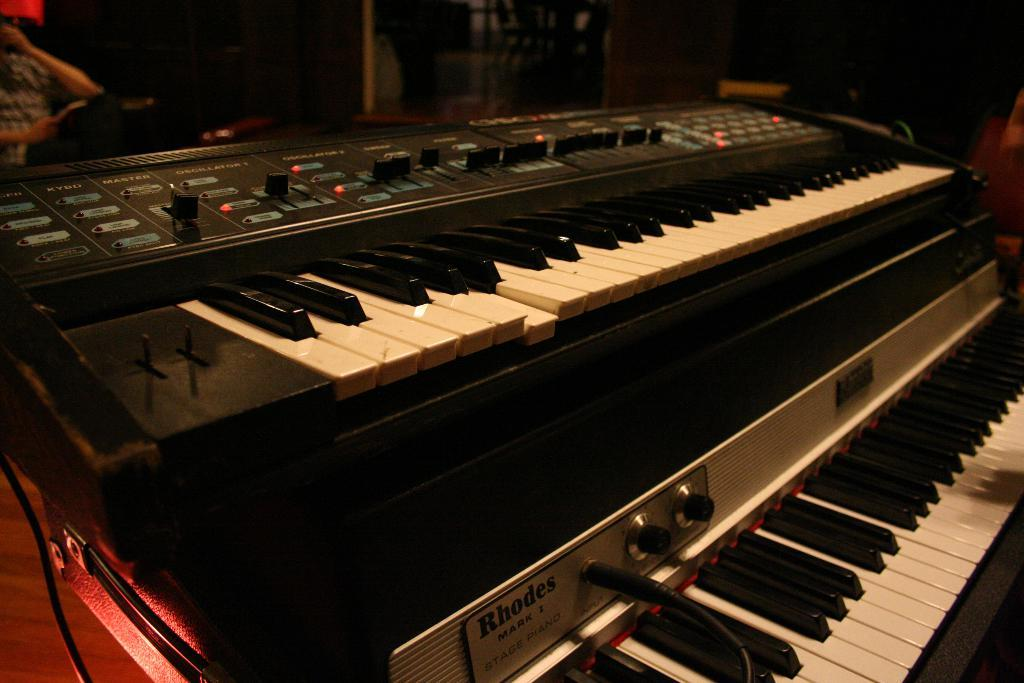What musical instrument is visible in the image? There is a piano keyboard in the image. Can you describe the person in the image? There is a person sitting in the image. Where is the lunchroom located in the image? There is no mention of a lunchroom in the image; it only features a piano keyboard and a person sitting. What position does the person have while sitting in the image? The position of the person sitting in the image cannot be determined from the provided facts. 